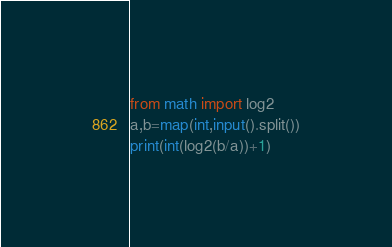Convert code to text. <code><loc_0><loc_0><loc_500><loc_500><_Python_>from math import log2
a,b=map(int,input().split())
print(int(log2(b/a))+1)</code> 